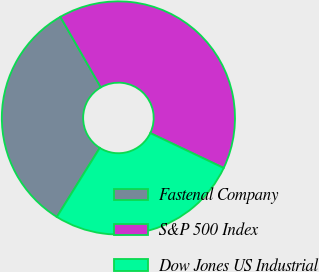Convert chart. <chart><loc_0><loc_0><loc_500><loc_500><pie_chart><fcel>Fastenal Company<fcel>S&P 500 Index<fcel>Dow Jones US Industrial<nl><fcel>32.86%<fcel>40.36%<fcel>26.79%<nl></chart> 